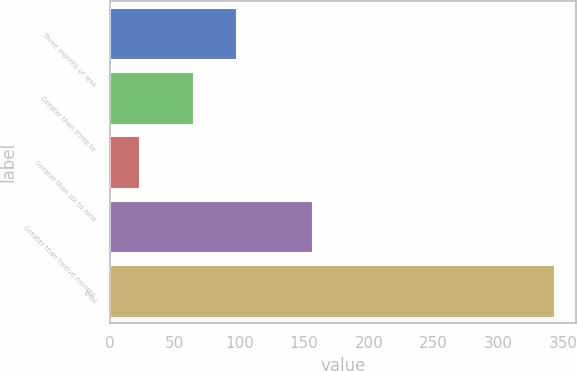Convert chart to OTSL. <chart><loc_0><loc_0><loc_500><loc_500><bar_chart><fcel>Three months or less<fcel>Greater than three to<fcel>Greater than six to nine<fcel>Greater than twelve months<fcel>Total<nl><fcel>97<fcel>64<fcel>22<fcel>156<fcel>343<nl></chart> 